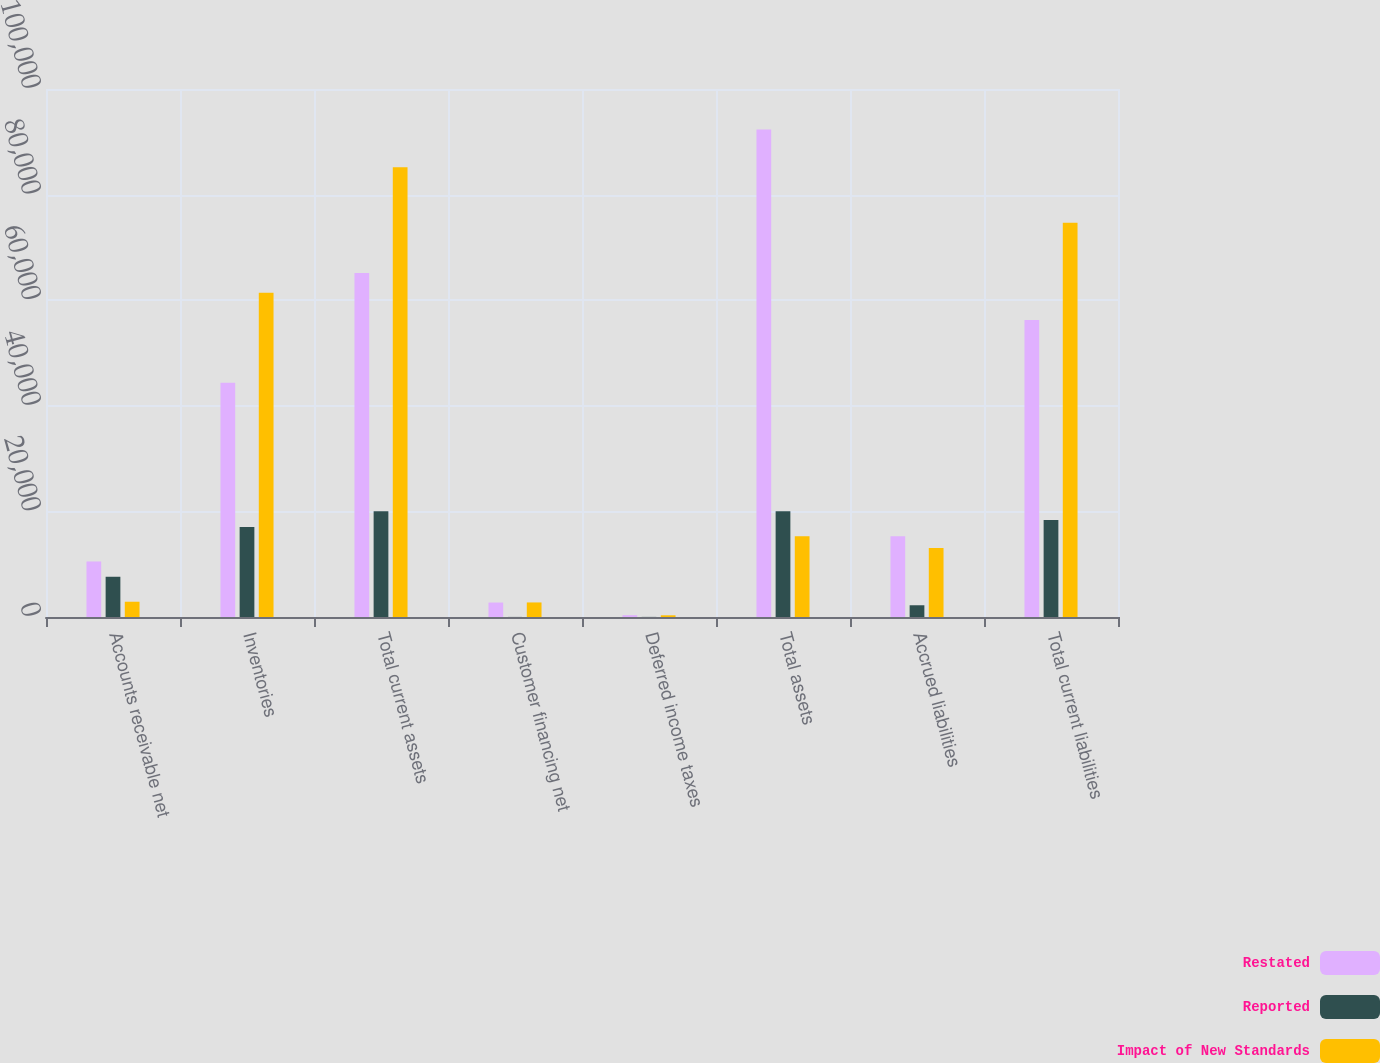<chart> <loc_0><loc_0><loc_500><loc_500><stacked_bar_chart><ecel><fcel>Accounts receivable net<fcel>Inventories<fcel>Total current assets<fcel>Customer financing net<fcel>Deferred income taxes<fcel>Total assets<fcel>Accrued liabilities<fcel>Total current liabilities<nl><fcel>Restated<fcel>10516<fcel>44344<fcel>65161<fcel>2740<fcel>341<fcel>92333<fcel>15292<fcel>56269<nl><fcel>Reported<fcel>7622<fcel>17044<fcel>20033<fcel>16<fcel>20<fcel>20029<fcel>2223<fcel>18379<nl><fcel>Impact of New Standards<fcel>2894<fcel>61388<fcel>85194<fcel>2756<fcel>321<fcel>15292<fcel>13069<fcel>74648<nl></chart> 